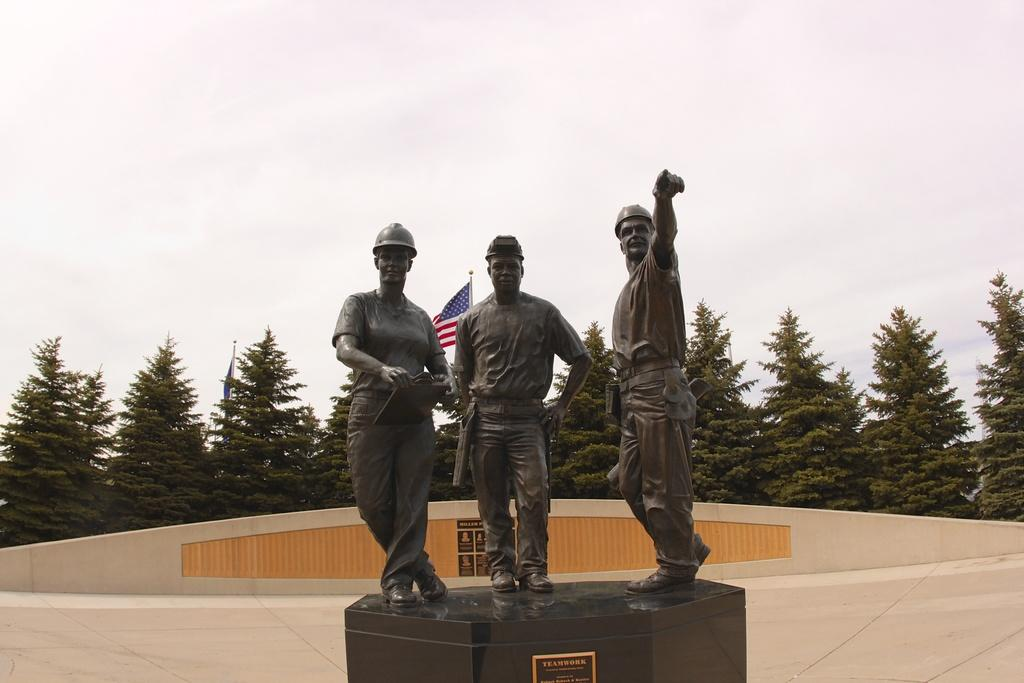What can be seen in the foreground of the picture? There are three statues in the foreground of the picture. What is located in the center of the picture? There is an inauguration stone and a flag in the center of the picture. What can be seen in the background of the picture? There are trees and the sky visible in the background of the picture. How many trucks are present in the image? There are no trucks visible in the image. Are there any fairies flying around the statues in the image? There are no fairies present in the image. 